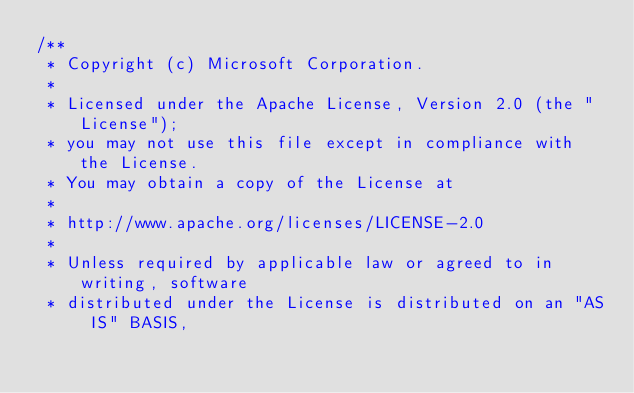Convert code to text. <code><loc_0><loc_0><loc_500><loc_500><_TypeScript_>/**
 * Copyright (c) Microsoft Corporation.
 *
 * Licensed under the Apache License, Version 2.0 (the "License");
 * you may not use this file except in compliance with the License.
 * You may obtain a copy of the License at
 *
 * http://www.apache.org/licenses/LICENSE-2.0
 *
 * Unless required by applicable law or agreed to in writing, software
 * distributed under the License is distributed on an "AS IS" BASIS,</code> 